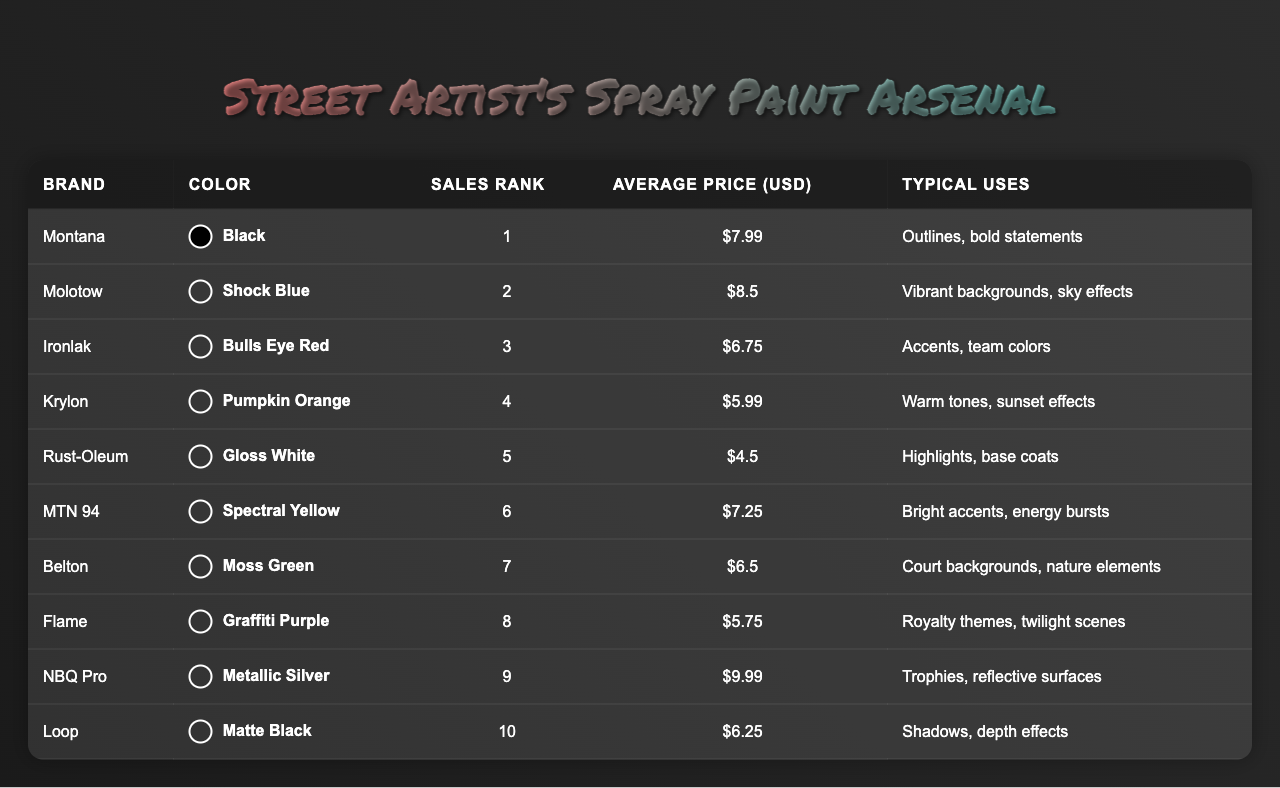What is the color used by the top-selling spray paint brand? The top-selling spray paint brand is Montana, and its color is Black.
Answer: Black Which brand has the highest average price? NBQ Pro has the highest average price at $9.99.
Answer: $9.99 What is the sales rank of Molotow? Molotow is ranked 2nd in sales.
Answer: 2 Which brand is associated with nature elements? Belton is associated with nature elements.
Answer: Belton How many brands have an average price lower than $6? There are two brands below $6, which are Rust-Oleum ($4.50) and Krylon ($5.99).
Answer: 2 What is the average price of the top three brands? The top three brands are Montana ($7.99), Molotow ($8.50), and Ironlak ($6.75). Their sum is $23.24, and the average is $23.24 / 3 = $7.75.
Answer: $7.75 True or false: Flame is used for warm tones and sunset effects. This is false as Flame is associated with royal themes and twilight scenes.
Answer: False Which colors can be used for warm tones? The colors suitable for warm tones are Krylon (Pumpkin Orange) and Flame (Graffiti Purple).
Answer: Pumpkin Orange, Graffiti Purple If a street artist wants to accentuate team colors, which spray paint should they choose? Ironlak (Bulls Eye Red) should be chosen, as it is specifically noted for that use.
Answer: Ironlak What is the difference in sales rank between the brand with the lowest average price and the highest? Rust-Oleum has the lowest average price ($4.50) with a sales rank of 5, while NBQ Pro has the highest average price ($9.99) with a rank of 9. The difference in rank is 9 - 5 = 4.
Answer: 4 